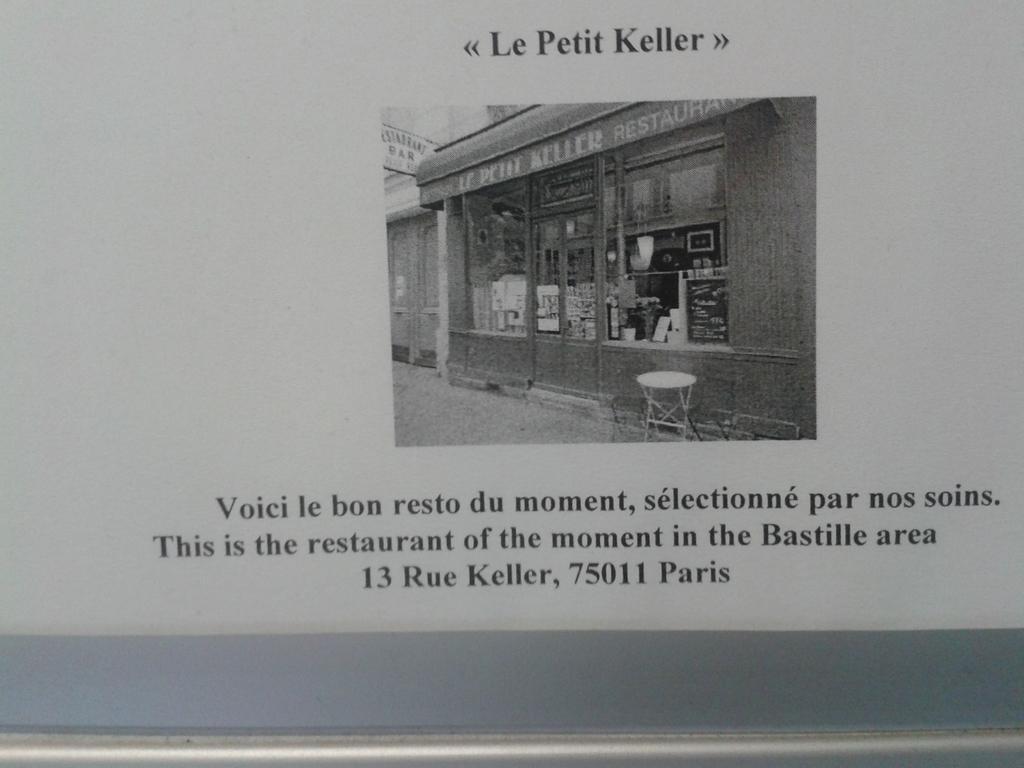Can you describe this image briefly? This looks like a poster. I can see the picture of a glass door. Here is a stool. This is the name board. These are the letters on the poster. 